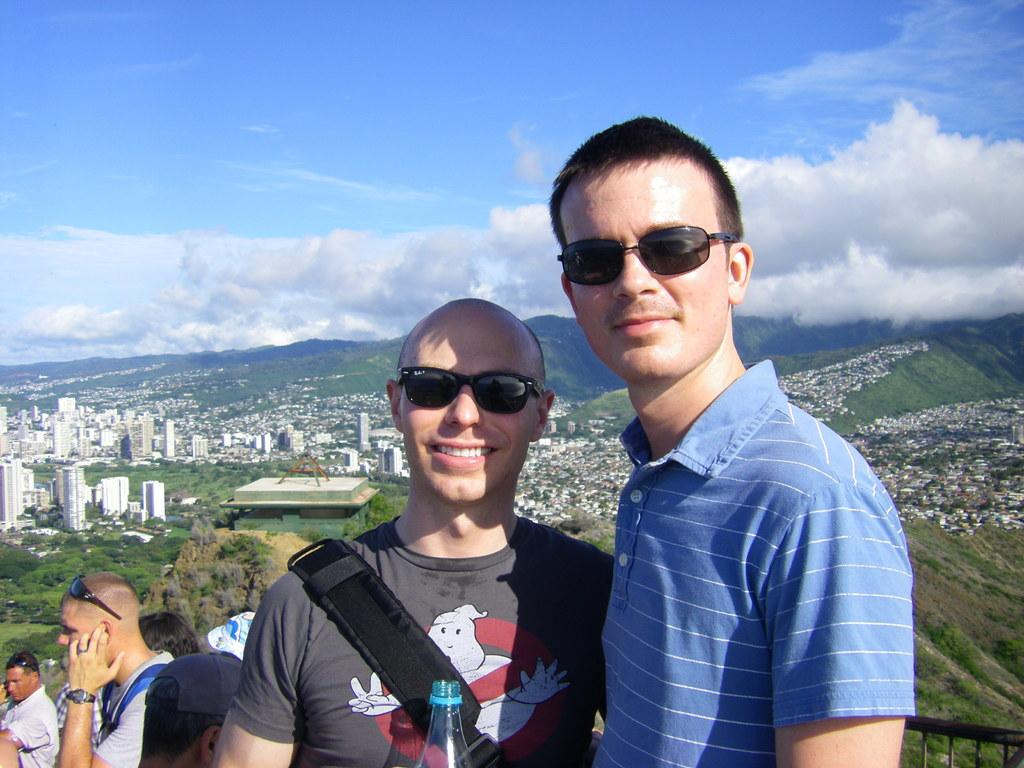What are the people in the image wearing? The people in the image are wearing bags and glasses. What can be seen in the background of the image? There are trees, buildings, and a mountain visible in the background of the image. What is the color of the sky in the image? The sky is blue and white in color. What type of ball can be heard in the image? There is no ball present in the image, and therefore no sound can be heard. 